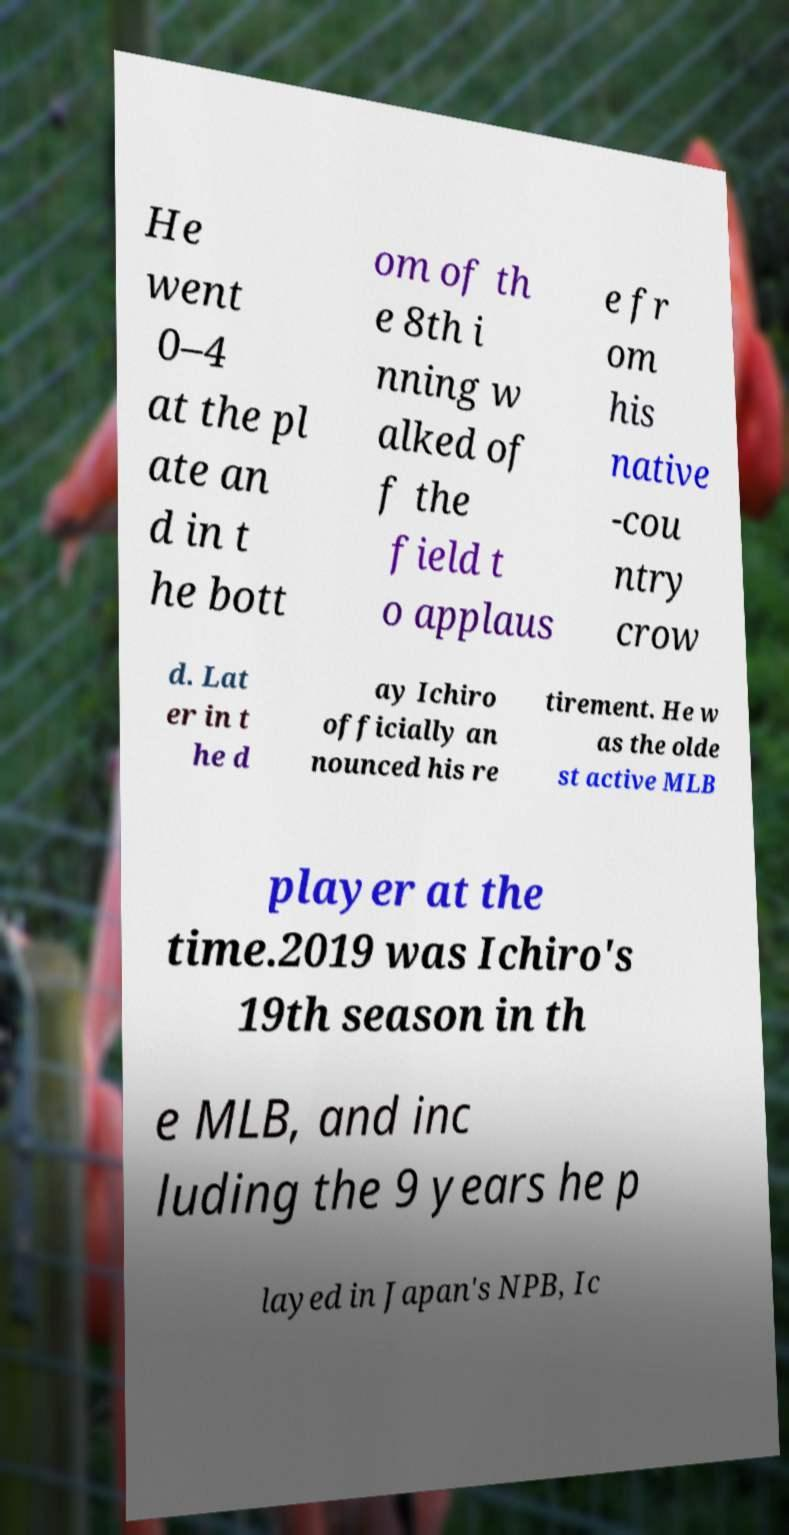Please identify and transcribe the text found in this image. He went 0–4 at the pl ate an d in t he bott om of th e 8th i nning w alked of f the field t o applaus e fr om his native -cou ntry crow d. Lat er in t he d ay Ichiro officially an nounced his re tirement. He w as the olde st active MLB player at the time.2019 was Ichiro's 19th season in th e MLB, and inc luding the 9 years he p layed in Japan's NPB, Ic 